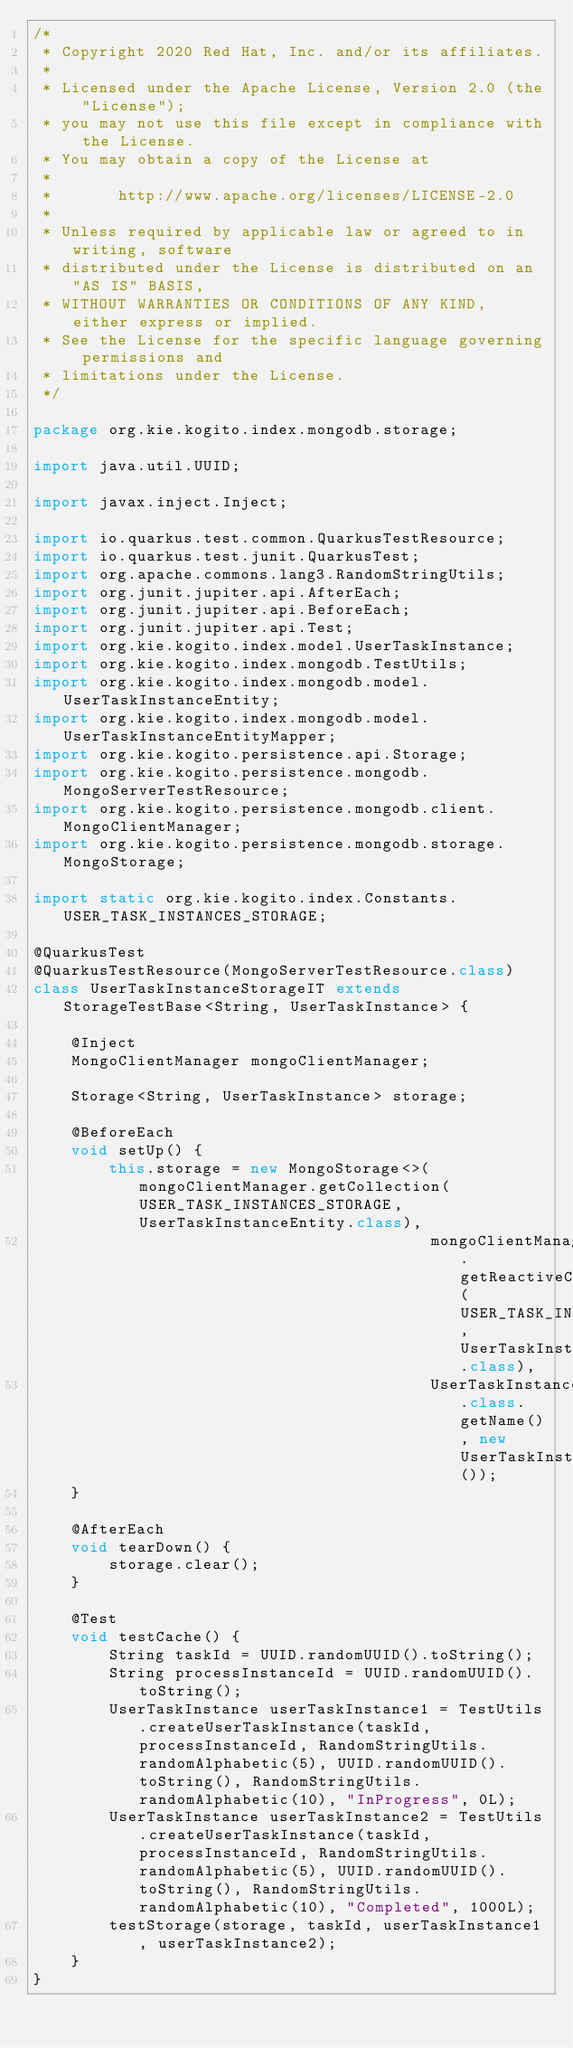<code> <loc_0><loc_0><loc_500><loc_500><_Java_>/*
 * Copyright 2020 Red Hat, Inc. and/or its affiliates.
 *
 * Licensed under the Apache License, Version 2.0 (the "License");
 * you may not use this file except in compliance with the License.
 * You may obtain a copy of the License at
 *
 *       http://www.apache.org/licenses/LICENSE-2.0
 *
 * Unless required by applicable law or agreed to in writing, software
 * distributed under the License is distributed on an "AS IS" BASIS,
 * WITHOUT WARRANTIES OR CONDITIONS OF ANY KIND, either express or implied.
 * See the License for the specific language governing permissions and
 * limitations under the License.
 */

package org.kie.kogito.index.mongodb.storage;

import java.util.UUID;

import javax.inject.Inject;

import io.quarkus.test.common.QuarkusTestResource;
import io.quarkus.test.junit.QuarkusTest;
import org.apache.commons.lang3.RandomStringUtils;
import org.junit.jupiter.api.AfterEach;
import org.junit.jupiter.api.BeforeEach;
import org.junit.jupiter.api.Test;
import org.kie.kogito.index.model.UserTaskInstance;
import org.kie.kogito.index.mongodb.TestUtils;
import org.kie.kogito.index.mongodb.model.UserTaskInstanceEntity;
import org.kie.kogito.index.mongodb.model.UserTaskInstanceEntityMapper;
import org.kie.kogito.persistence.api.Storage;
import org.kie.kogito.persistence.mongodb.MongoServerTestResource;
import org.kie.kogito.persistence.mongodb.client.MongoClientManager;
import org.kie.kogito.persistence.mongodb.storage.MongoStorage;

import static org.kie.kogito.index.Constants.USER_TASK_INSTANCES_STORAGE;

@QuarkusTest
@QuarkusTestResource(MongoServerTestResource.class)
class UserTaskInstanceStorageIT extends StorageTestBase<String, UserTaskInstance> {

    @Inject
    MongoClientManager mongoClientManager;

    Storage<String, UserTaskInstance> storage;

    @BeforeEach
    void setUp() {
        this.storage = new MongoStorage<>(mongoClientManager.getCollection(USER_TASK_INSTANCES_STORAGE, UserTaskInstanceEntity.class),
                                          mongoClientManager.getReactiveCollection(USER_TASK_INSTANCES_STORAGE, UserTaskInstanceEntity.class),
                                          UserTaskInstance.class.getName(), new UserTaskInstanceEntityMapper());
    }

    @AfterEach
    void tearDown() {
        storage.clear();
    }

    @Test
    void testCache() {
        String taskId = UUID.randomUUID().toString();
        String processInstanceId = UUID.randomUUID().toString();
        UserTaskInstance userTaskInstance1 = TestUtils.createUserTaskInstance(taskId, processInstanceId, RandomStringUtils.randomAlphabetic(5), UUID.randomUUID().toString(), RandomStringUtils.randomAlphabetic(10), "InProgress", 0L);
        UserTaskInstance userTaskInstance2 = TestUtils.createUserTaskInstance(taskId, processInstanceId, RandomStringUtils.randomAlphabetic(5), UUID.randomUUID().toString(), RandomStringUtils.randomAlphabetic(10), "Completed", 1000L);
        testStorage(storage, taskId, userTaskInstance1, userTaskInstance2);
    }
}
</code> 